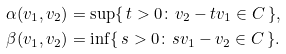Convert formula to latex. <formula><loc_0><loc_0><loc_500><loc_500>\alpha ( v _ { 1 } , v _ { 2 } ) & = \sup \{ \, t > 0 \colon v _ { 2 } - t v _ { 1 } \in C \, \} , \\ \beta ( v _ { 1 } , v _ { 2 } ) & = \inf \{ \, s > 0 \colon s v _ { 1 } - v _ { 2 } \in C \, \} .</formula> 